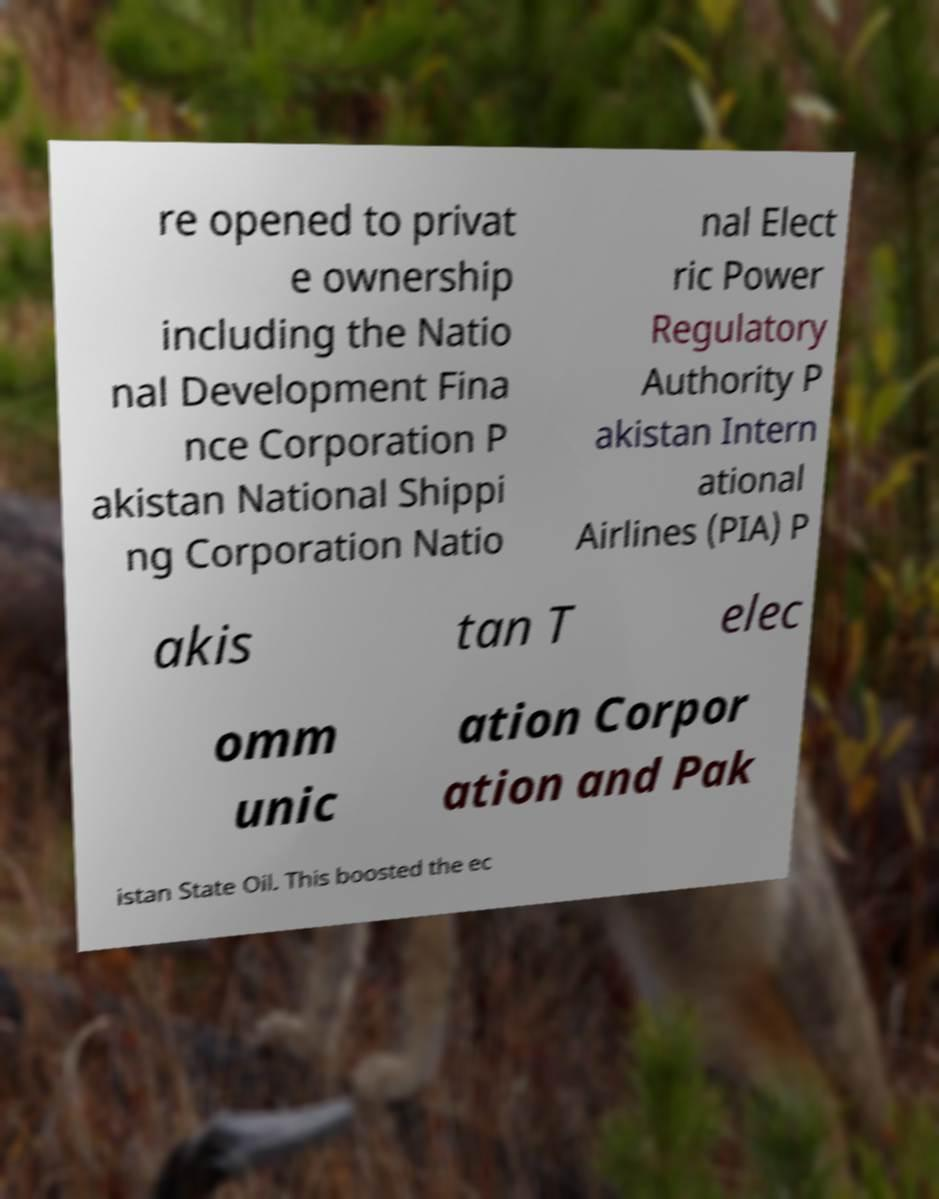Please read and relay the text visible in this image. What does it say? re opened to privat e ownership including the Natio nal Development Fina nce Corporation P akistan National Shippi ng Corporation Natio nal Elect ric Power Regulatory Authority P akistan Intern ational Airlines (PIA) P akis tan T elec omm unic ation Corpor ation and Pak istan State Oil. This boosted the ec 